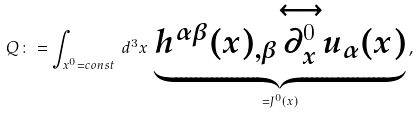Convert formula to latex. <formula><loc_0><loc_0><loc_500><loc_500>Q \colon = \int _ { x ^ { 0 } = c o n s t } \, d ^ { 3 } x \, \underbrace { h ^ { \alpha \beta } ( x ) _ { , \beta } { \stackrel { \longleftrightarrow } { \partial _ { x } ^ { 0 } } } u _ { \alpha } ( x ) } _ { = J ^ { 0 } ( x ) } \, ,</formula> 